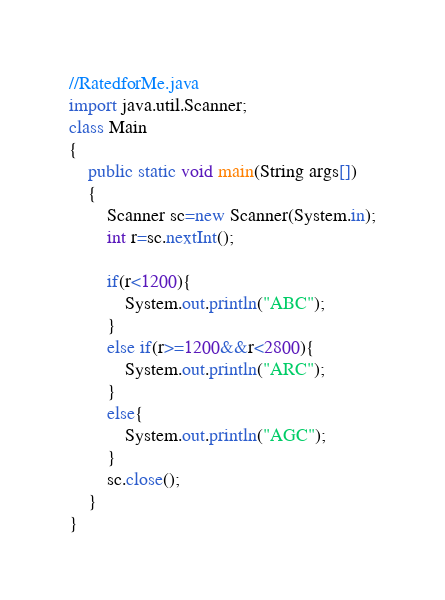Convert code to text. <code><loc_0><loc_0><loc_500><loc_500><_Java_>//RatedforMe.java
import java.util.Scanner;
class Main
{
	public static void main(String args[])
	{
		Scanner sc=new Scanner(System.in);
        int r=sc.nextInt();
        
        if(r<1200){
            System.out.println("ABC");
        }
        else if(r>=1200&&r<2800){
            System.out.println("ARC");
        }
        else{
            System.out.println("AGC");
        }
        sc.close();
    }
}</code> 